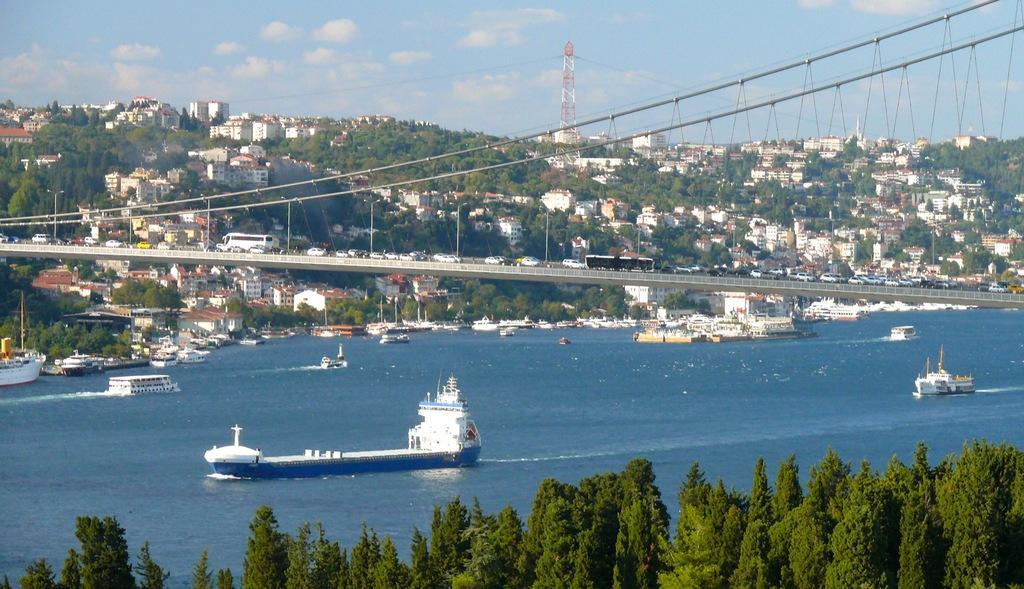In one or two sentences, can you explain what this image depicts? In this picture there is a white and blue boat in the river. Behind there is a iron suspension bridge. In the background there are many buildings and houses on the mountain. In the front bottom side there are some trees. 